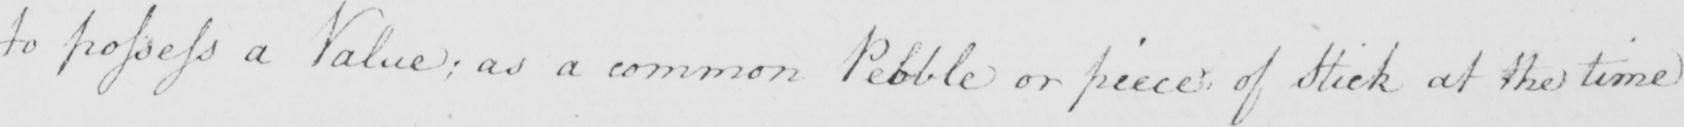What text is written in this handwritten line? to possess a Value ; as a common Pebble or piece of Stick at the time 